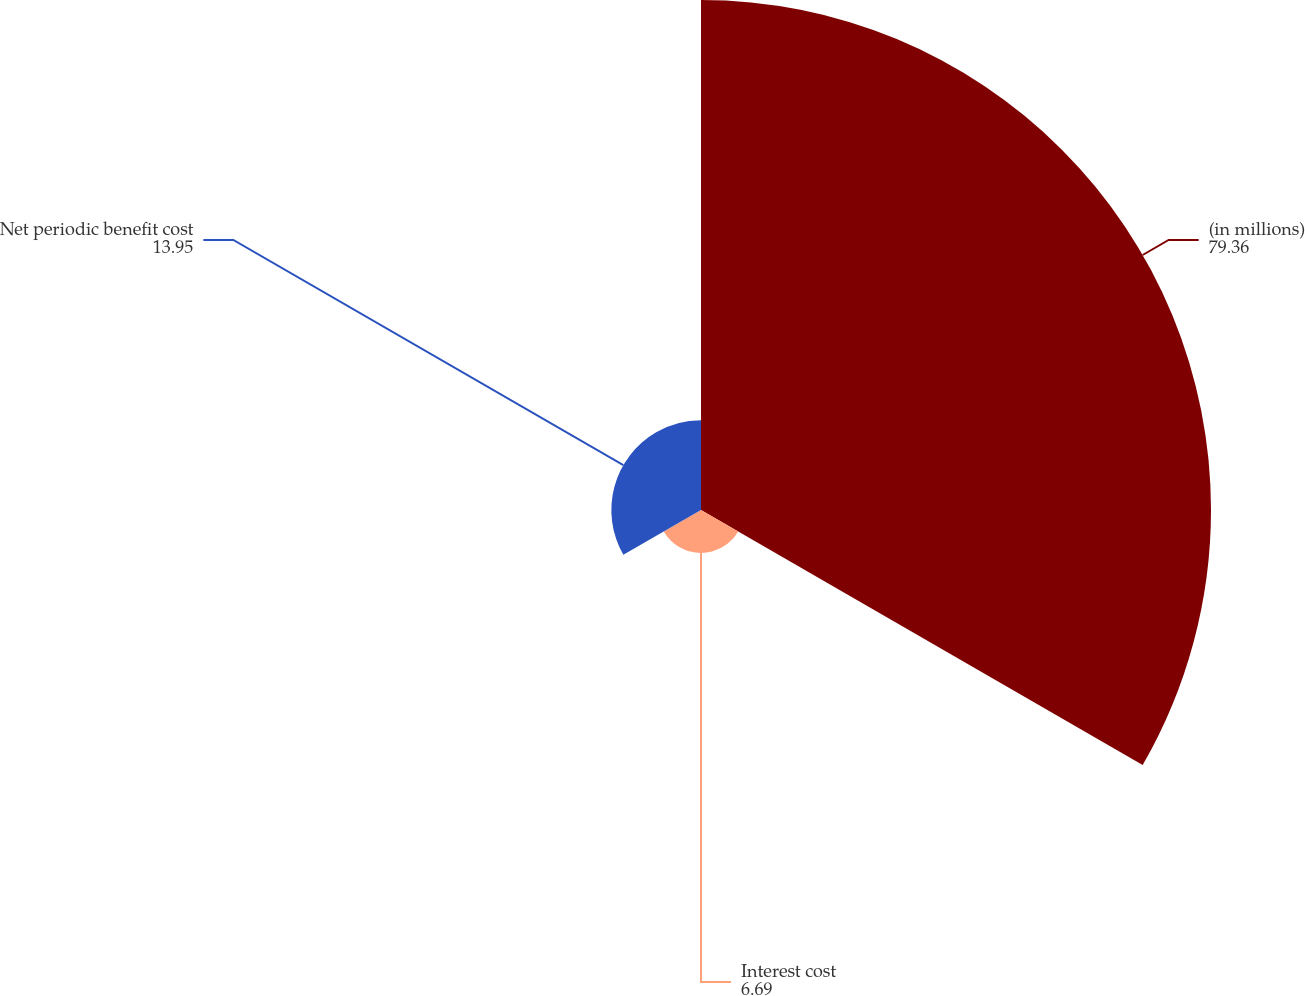Convert chart. <chart><loc_0><loc_0><loc_500><loc_500><pie_chart><fcel>(in millions)<fcel>Interest cost<fcel>Net periodic benefit cost<nl><fcel>79.36%<fcel>6.69%<fcel>13.95%<nl></chart> 